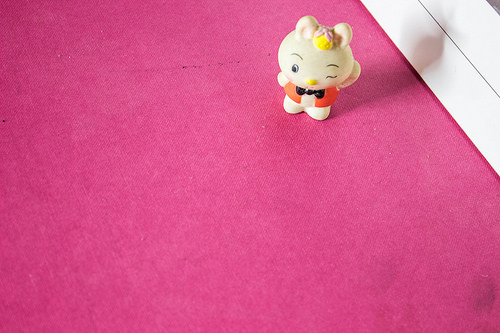<image>
Is the toy next to the door? Yes. The toy is positioned adjacent to the door, located nearby in the same general area. Is there a toy above the carpet? No. The toy is not positioned above the carpet. The vertical arrangement shows a different relationship. 